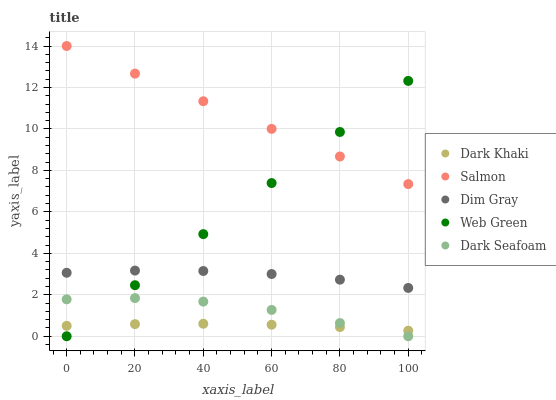Does Dark Khaki have the minimum area under the curve?
Answer yes or no. Yes. Does Salmon have the maximum area under the curve?
Answer yes or no. Yes. Does Dark Seafoam have the minimum area under the curve?
Answer yes or no. No. Does Dark Seafoam have the maximum area under the curve?
Answer yes or no. No. Is Salmon the smoothest?
Answer yes or no. Yes. Is Dark Seafoam the roughest?
Answer yes or no. Yes. Is Dim Gray the smoothest?
Answer yes or no. No. Is Dim Gray the roughest?
Answer yes or no. No. Does Dark Seafoam have the lowest value?
Answer yes or no. Yes. Does Dim Gray have the lowest value?
Answer yes or no. No. Does Salmon have the highest value?
Answer yes or no. Yes. Does Dark Seafoam have the highest value?
Answer yes or no. No. Is Dark Seafoam less than Salmon?
Answer yes or no. Yes. Is Dim Gray greater than Dark Khaki?
Answer yes or no. Yes. Does Web Green intersect Dark Seafoam?
Answer yes or no. Yes. Is Web Green less than Dark Seafoam?
Answer yes or no. No. Is Web Green greater than Dark Seafoam?
Answer yes or no. No. Does Dark Seafoam intersect Salmon?
Answer yes or no. No. 